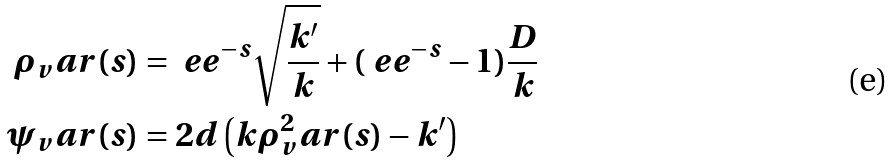<formula> <loc_0><loc_0><loc_500><loc_500>\rho _ { v } a r ( s ) & = \ e e ^ { - s } \sqrt { \frac { k ^ { \prime } } { k } } + ( \ e e ^ { - s } - 1 ) \frac { D } { k } \\ \psi _ { v } a r ( s ) & = 2 d \left ( k \rho ^ { 2 } _ { v } a r ( s ) - k ^ { \prime } \right )</formula> 